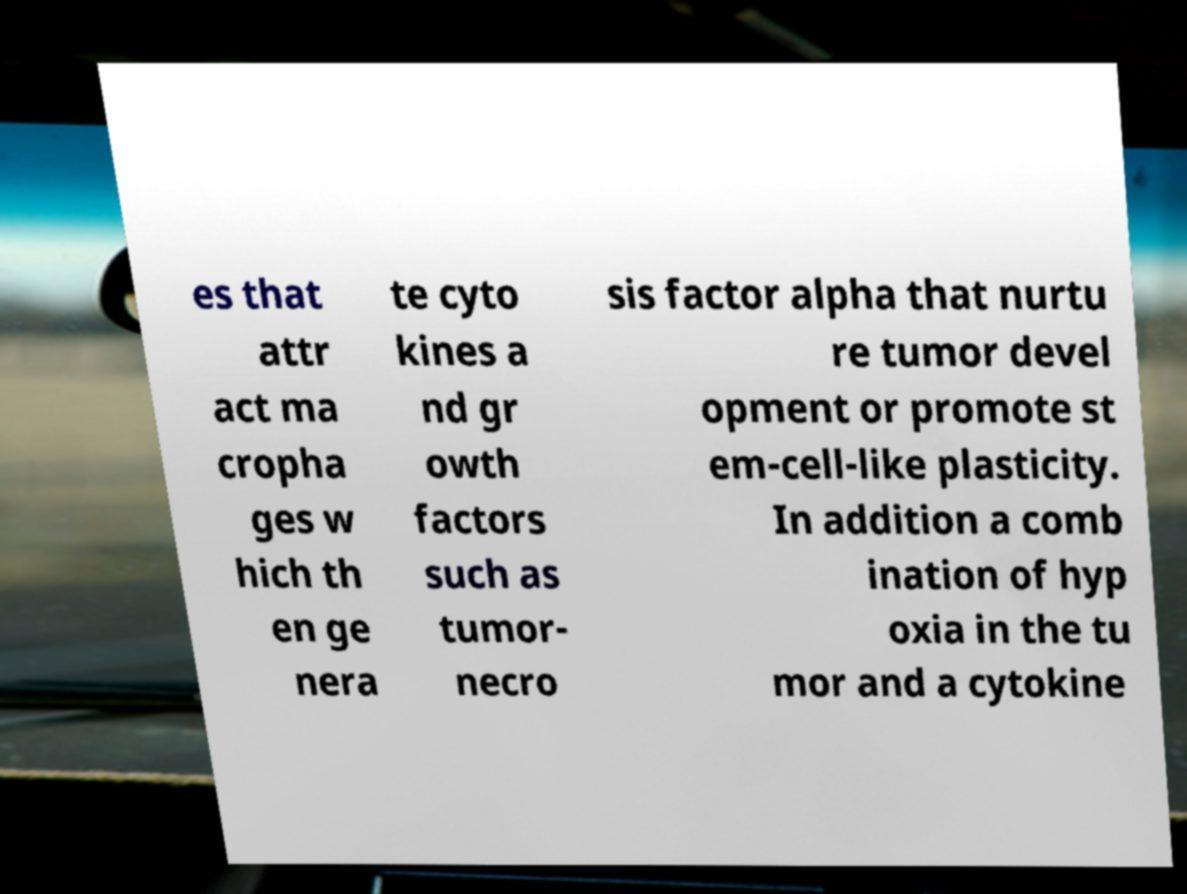Can you read and provide the text displayed in the image?This photo seems to have some interesting text. Can you extract and type it out for me? es that attr act ma cropha ges w hich th en ge nera te cyto kines a nd gr owth factors such as tumor- necro sis factor alpha that nurtu re tumor devel opment or promote st em-cell-like plasticity. In addition a comb ination of hyp oxia in the tu mor and a cytokine 